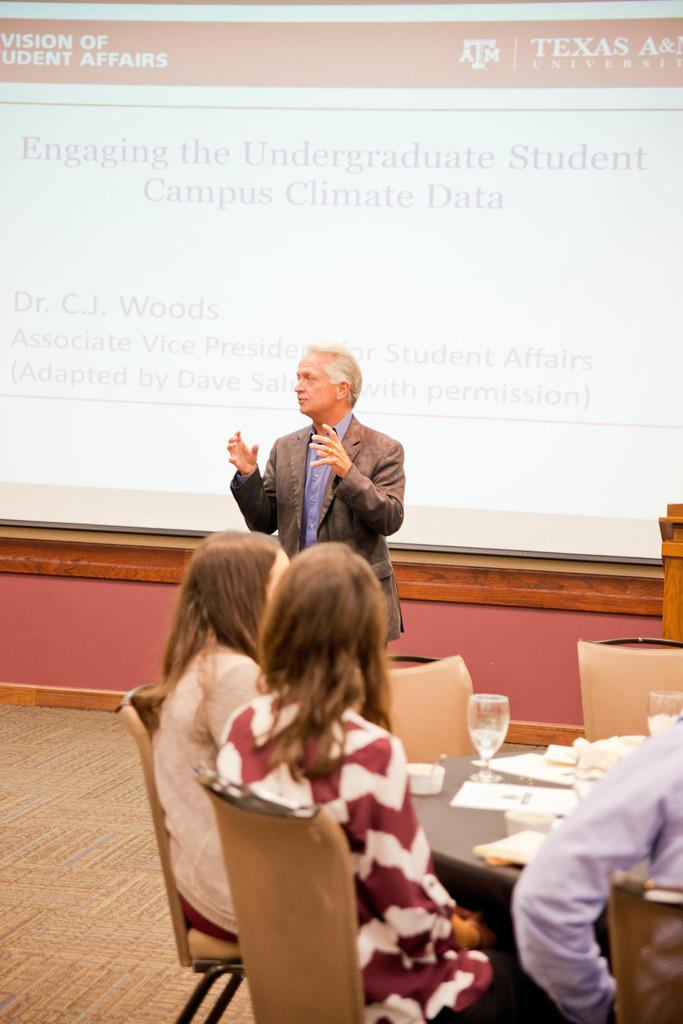What is the man in the image doing? The man is speaking in the image. Who is the man speaking to? There are people sitting in front of the man. What is between the man and the people? There is a table in front of the man and the people. What can be found on the table? The table has tissues and wine glasses on it. How does the man push the oatmeletmeal around the table in the image? There is no oatmeal present in the image, so the man cannot push it around the table. 